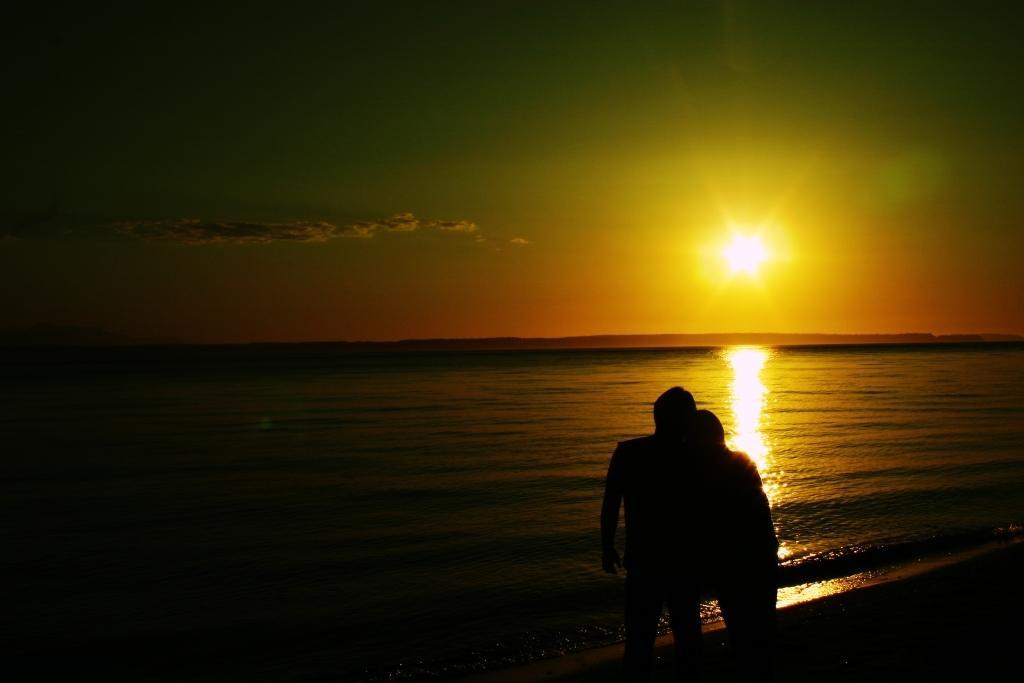Could you give a brief overview of what you see in this image? In this image we can see two persons standing at the sea shore hugging each other and at the background of the image there is water, sunset and orange color sky. 